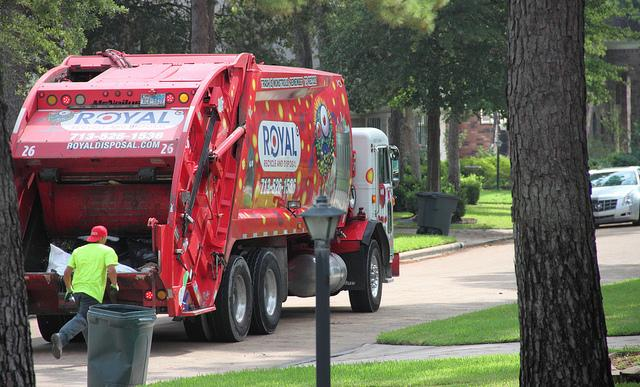What is being gathered by this vehicle?

Choices:
A) paper
B) children
C) ice cream
D) garbage garbage 